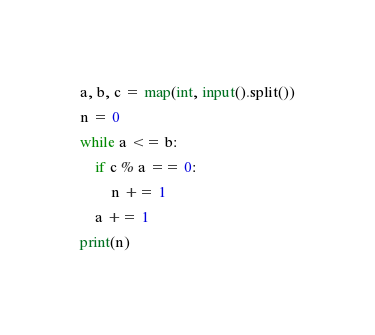Convert code to text. <code><loc_0><loc_0><loc_500><loc_500><_Python_>a, b, c = map(int, input().split())
n = 0
while a <= b:
    if c % a == 0:
        n += 1
    a += 1
print(n)

</code> 